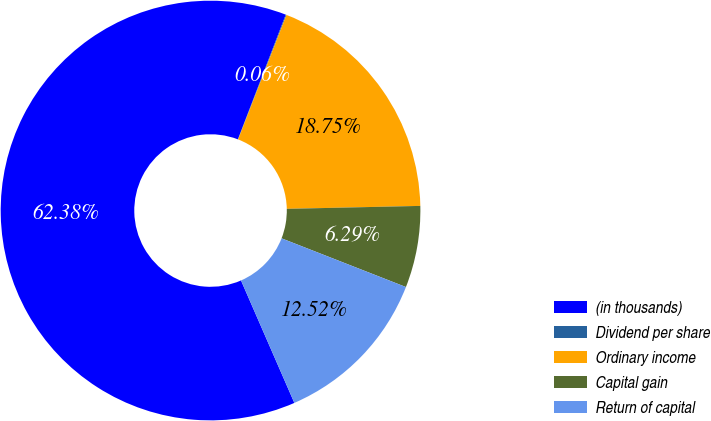Convert chart. <chart><loc_0><loc_0><loc_500><loc_500><pie_chart><fcel>(in thousands)<fcel>Dividend per share<fcel>Ordinary income<fcel>Capital gain<fcel>Return of capital<nl><fcel>62.37%<fcel>0.06%<fcel>18.75%<fcel>6.29%<fcel>12.52%<nl></chart> 